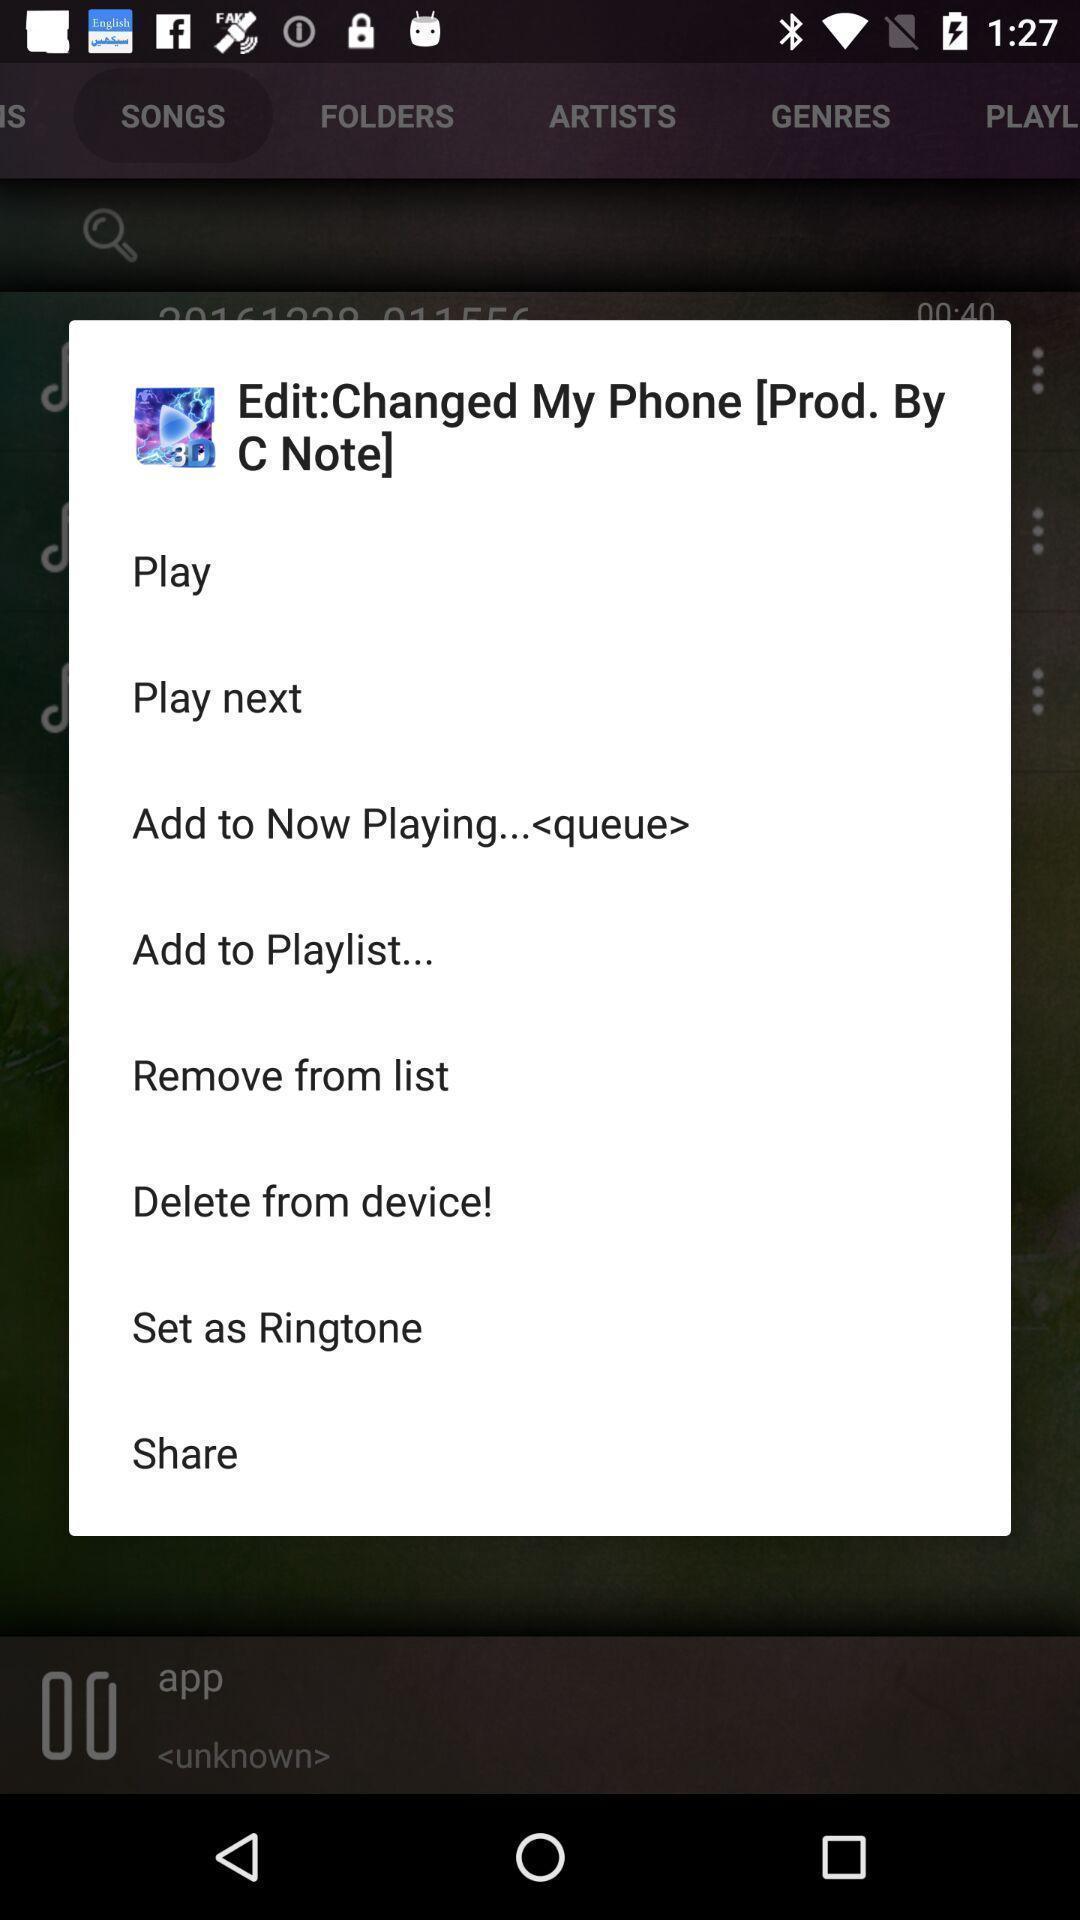Provide a textual representation of this image. Pop-up showing multiple options to play a song. 